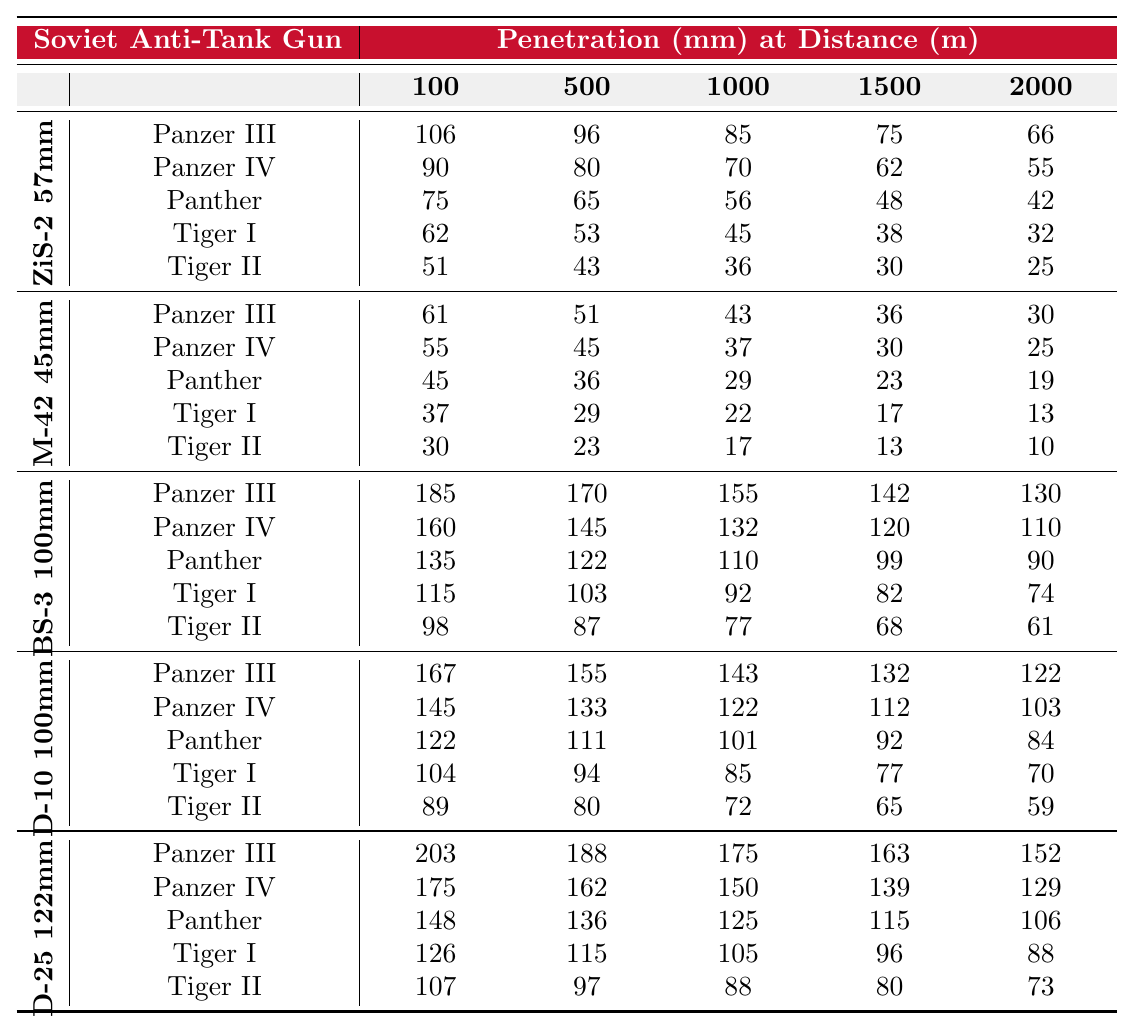What is the penetration of the ZiS-2 57mm against the Tiger I at 100 meters? The table shows that the penetration capability of the ZiS-2 57mm against the Tiger I at 100 meters is 62 mm.
Answer: 62 mm Which gun has the highest penetration against the Panther at 100 meters? The BS-3 100mm has the highest penetration against the Panther at 100 meters with a value of 135 mm.
Answer: 135 mm Is the penetration of the M-42 45mm against the Panzer IV greater than 50 mm at 500 meters? The M-42 45mm penetrates the Panzer IV with 45 mm at 500 meters, which is not greater than 50 mm, so the answer is no.
Answer: No At which distance does the D-25 122mm provide the lowest penetration against the Tiger II? By evaluating the table, the lowest penetration of the D-25 122mm against the Tiger II is 73 mm at 2000 meters.
Answer: 73 mm What is the average penetration of the D-10 100mm against the Panzer III at distances of 100, 500, and 1000 meters? The penetrations at those distances are 167 mm, 155 mm, and 143 mm. The average is calculated as (167 + 155 + 143) / 3 = 155 mm.
Answer: 155 mm Which Soviet anti-tank gun shows a significant improvement in penetration against the Panzer III from 100 meters to 2000 meters? The D-25 122mm shows a significant improvement, increasing from 203 mm at 100 meters to 152 mm at 2000 meters.
Answer: D-25 122mm What is the difference in penetration between the BS-3 100mm and the D-10 100mm against the Tiger I at 1500 meters? The penetration of the BS-3 100mm is 82 mm and the D-10 100mm is 77 mm, so the difference is 82 mm - 77 mm = 5 mm.
Answer: 5 mm Does the M-42 45mm penetrate the Tiger II at any distance listed in the table? The M-42 45mm penetrates the Tiger II with a maximum of 30 mm at 1000 meters, which qualifies as penetration.
Answer: Yes What is the maximum penetration of the ZiS-2 57mm across all distances against any tank? The maximum penetration for the ZiS-2 57mm is 106 mm against the Panzer III at 100 meters.
Answer: 106 mm Which gun is generally more effective against German armor, the D-25 122mm or the BS-3 100mm, based on the penetrations at 1000 meters? At 1000 meters, the D-25 122mm has a penetration of 175 mm against the Panzer IV, while the BS-3 100mm has 155 mm against the Panther, making the D-25 more effective.
Answer: D-25 122mm 